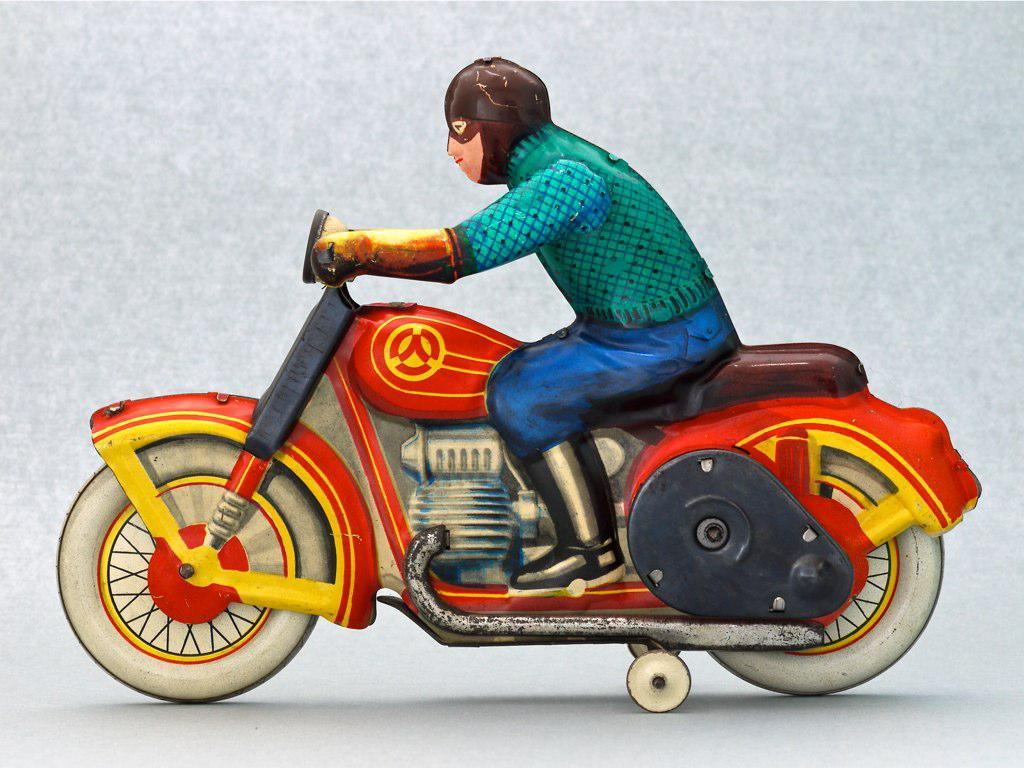What type of character is depicted in the image? There is a cartoon character in the image. What is the cartoon character doing in the image? The cartoon character is sitting on a bike. What safety precaution is the cartoon character taking? The cartoon character is wearing a helmet. What type of destruction is the cartoon character causing in the image? There is no destruction depicted in the image; the cartoon character is simply sitting on a bike and wearing a helmet. 